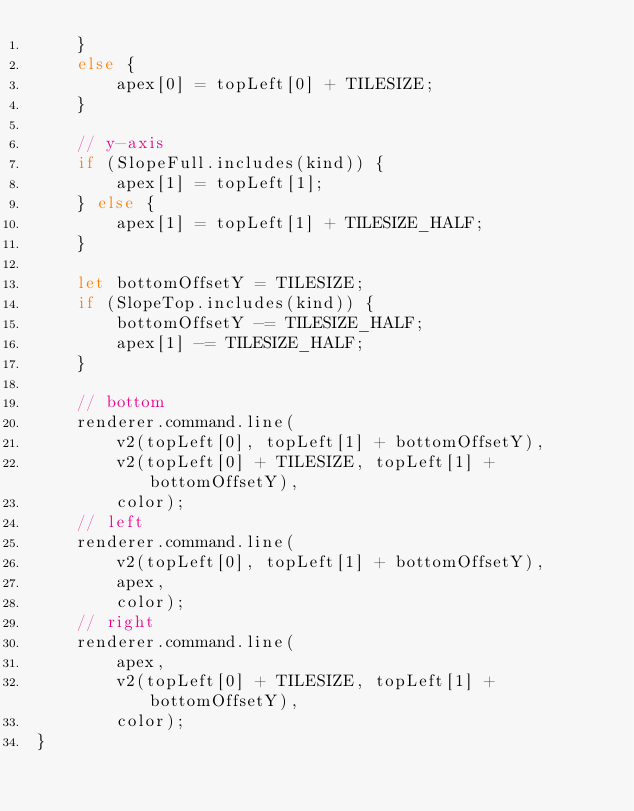<code> <loc_0><loc_0><loc_500><loc_500><_TypeScript_>    }
    else {
        apex[0] = topLeft[0] + TILESIZE;
    }

    // y-axis
    if (SlopeFull.includes(kind)) {
        apex[1] = topLeft[1];
    } else {
        apex[1] = topLeft[1] + TILESIZE_HALF;
    }

    let bottomOffsetY = TILESIZE;
    if (SlopeTop.includes(kind)) {
        bottomOffsetY -= TILESIZE_HALF;
        apex[1] -= TILESIZE_HALF;
    }

    // bottom
    renderer.command.line(
        v2(topLeft[0], topLeft[1] + bottomOffsetY),
        v2(topLeft[0] + TILESIZE, topLeft[1] + bottomOffsetY),
        color);
    // left
    renderer.command.line(
        v2(topLeft[0], topLeft[1] + bottomOffsetY),
        apex,
        color);
    // right
    renderer.command.line(
        apex,
        v2(topLeft[0] + TILESIZE, topLeft[1] + bottomOffsetY),
        color);
}</code> 